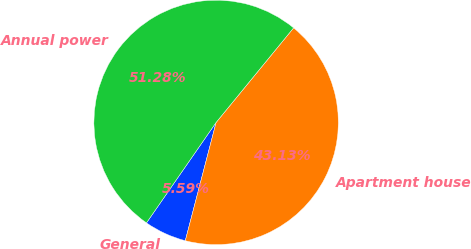Convert chart to OTSL. <chart><loc_0><loc_0><loc_500><loc_500><pie_chart><fcel>General<fcel>Apartment house<fcel>Annual power<nl><fcel>5.59%<fcel>43.13%<fcel>51.28%<nl></chart> 